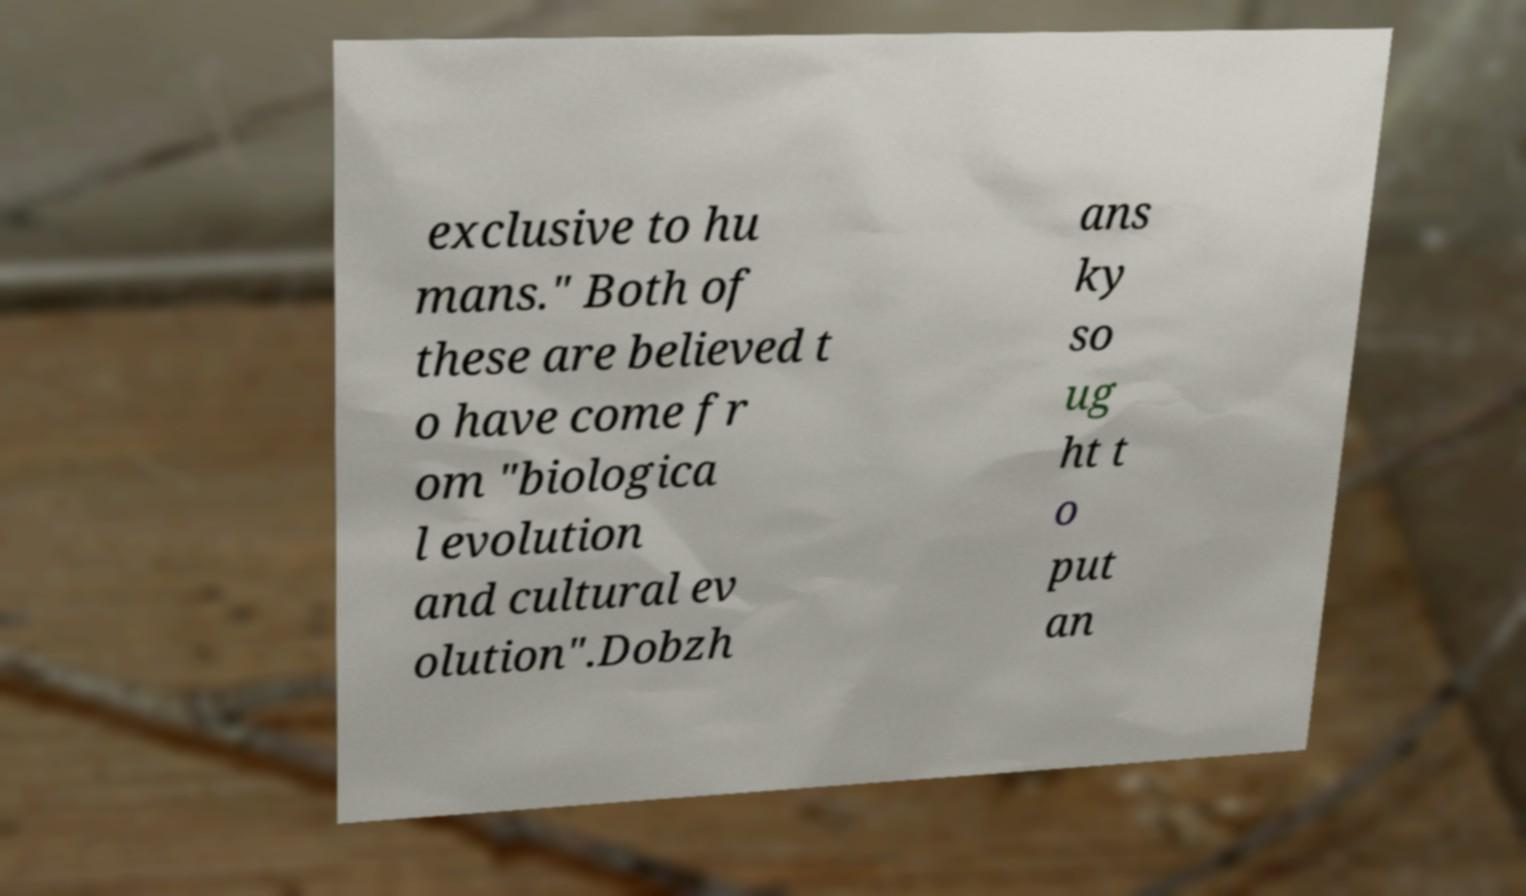For documentation purposes, I need the text within this image transcribed. Could you provide that? exclusive to hu mans." Both of these are believed t o have come fr om "biologica l evolution and cultural ev olution".Dobzh ans ky so ug ht t o put an 